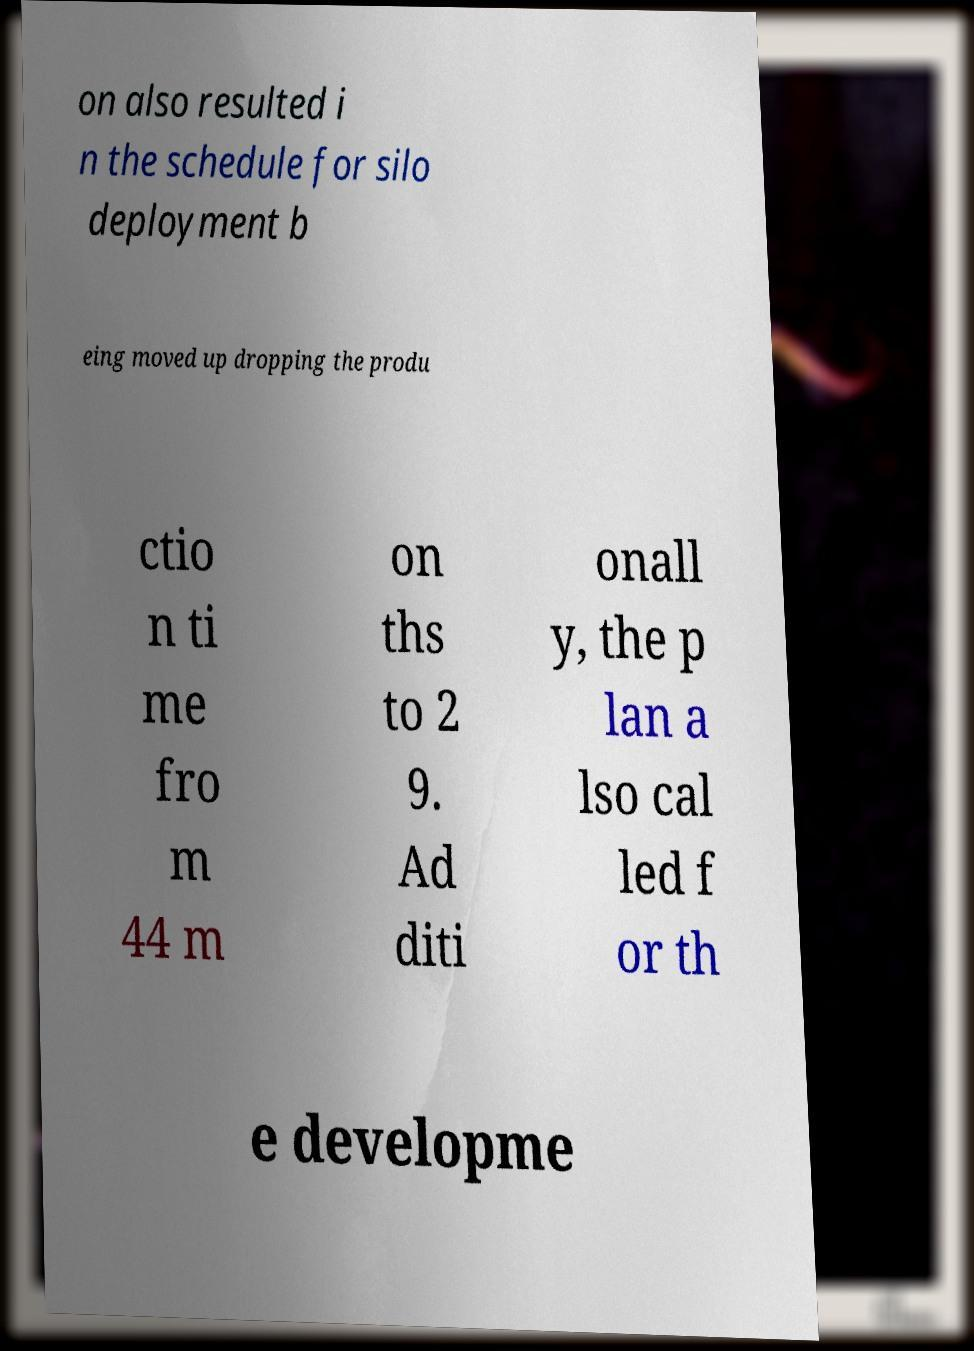Could you assist in decoding the text presented in this image and type it out clearly? on also resulted i n the schedule for silo deployment b eing moved up dropping the produ ctio n ti me fro m 44 m on ths to 2 9. Ad diti onall y, the p lan a lso cal led f or th e developme 